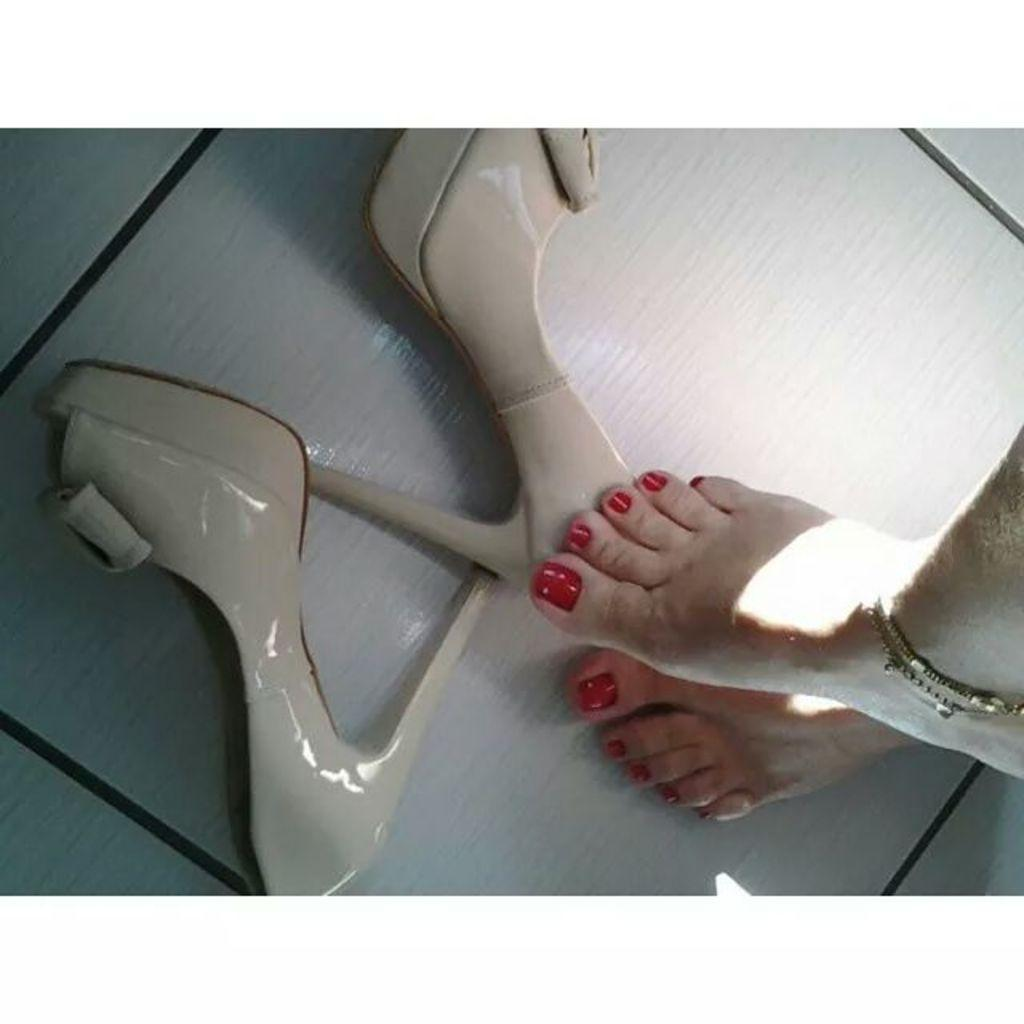What body parts are visible in the image? There are women's legs visible in the image. What type of footwear is present in the image? The image shows women's heels on the floor. Can you describe the setting where the image might have been taken? The image may have been taken in a hall. What type of maid is present in the image? There is no maid present in the image. What color is the wall in the image? There is no wall visible in the image. --- Facts: 1. There is a person holding a book in the image. 2. The book has a blue cover. 3. The person is sitting on a chair. 4. There is a table next to the chair. 5. The table has a lamp on it. Absurd Topics: horse, ocean, bicycle Conversation: What is the person in the image holding? The person is holding a book in the image. What color is the book's cover? The book has a blue cover. Where is the person sitting in the image? The person is sitting on a chair. What is located next to the chair? There is a table next to the chair. What object is on the table? The table has a lamp on it. Reasoning: Let's think step by step in order to produce the conversation. We start by identifying the main subject in the image, which is the person holding a book. Then, we expand the conversation to include other details that are also visible, such as the book's blue cover, the chair, the table, and the lamp. Each question is designed to elicit a specific detail about the image that is known from the provided facts. Absurd Question/Answer: Can you see any horses or oceans in the image? No, there are no horses or oceans present in the image. Is the person riding a bicycle in the image? No, the person is sitting on a chair and not riding a bicycle. 